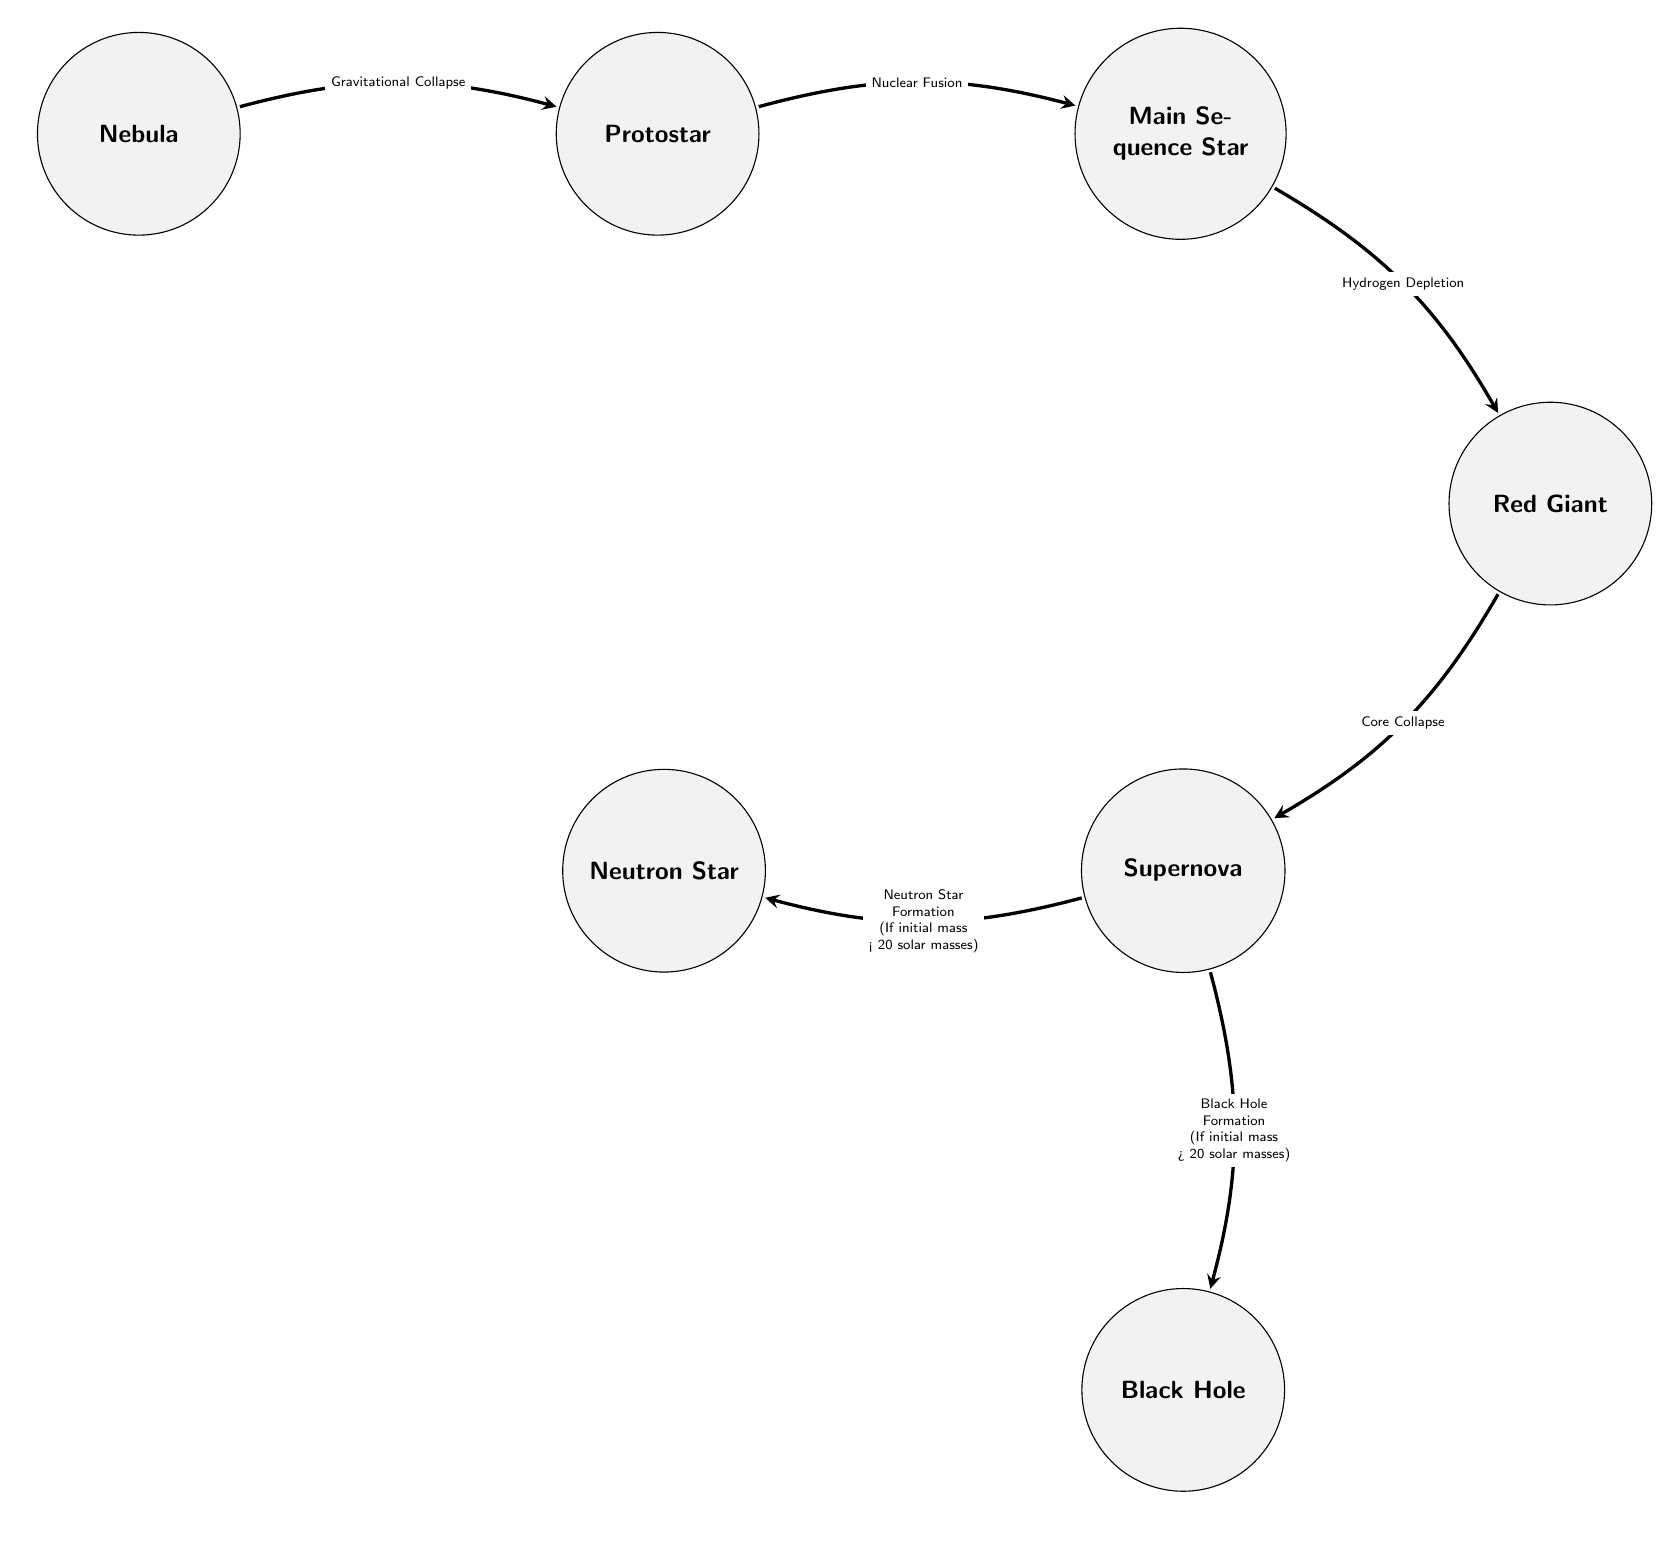What is the first stage of a celestial object's life cycle? The diagram clearly indicates that the first stage is represented by the "Nebula" node, which is positioned on the left side of the diagram.
Answer: Nebula How many stages are depicted in the diagram? By counting the nodes from "Nebula" to "Black Hole," we find a total of 7 distinct stages represented in the diagram.
Answer: 7 What is the transformation that occurs from Protostar to Main Sequence Star? The transformation indicated by the arrow between the "Protostar" and "Main Sequence Star" nodes is labeled as "Nuclear Fusion," revealing the process that leads to this transformation.
Answer: Nuclear Fusion What is the relationship between Red Giant and Supernova? The diagram shows an arrow leading from "Red Giant" to "Supernova," which signifies that the Red Giant stage is a prerequisite for the Supernova event.
Answer: Prerequisite What forms if the initial mass is less than 20 solar masses? The diagram indicates that if the stellar mass is below this threshold, a "Neutron Star" is formed, as indicated by the labels connected to the "Supernova" node.
Answer: Neutron Star What happens during Hydrogen Depletion? The node for "Main Sequence Star" to "Red Giant" shows that during the transition, "Hydrogen Depletion" occurs, indicating the consumption of hydrogen fuel leading to the subsequent stage.
Answer: Hydrogen Depletion Which stage leads directly to a Black Hole formation? The diagram links the transformation from "Supernova" to "Black Hole" specifically for cases where the initial mass is greater than 20 solar masses. This indicates that Black Hole formation is contingent upon the mass exceeding this limit.
Answer: Black Hole What is the final stage in the life cycle of a celestial object according to the diagram? The last node, located at the bottom right, is labeled "Black Hole," confirming that this is the final stage of a celestial object's life cycle as represented in the diagram.
Answer: Black Hole 